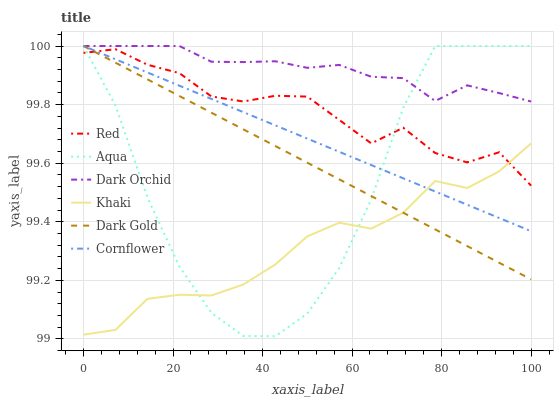Does Khaki have the minimum area under the curve?
Answer yes or no. Yes. Does Dark Orchid have the maximum area under the curve?
Answer yes or no. Yes. Does Dark Gold have the minimum area under the curve?
Answer yes or no. No. Does Dark Gold have the maximum area under the curve?
Answer yes or no. No. Is Cornflower the smoothest?
Answer yes or no. Yes. Is Aqua the roughest?
Answer yes or no. Yes. Is Khaki the smoothest?
Answer yes or no. No. Is Khaki the roughest?
Answer yes or no. No. Does Khaki have the lowest value?
Answer yes or no. No. Does Dark Orchid have the highest value?
Answer yes or no. Yes. Does Khaki have the highest value?
Answer yes or no. No. Is Khaki less than Dark Orchid?
Answer yes or no. Yes. Is Dark Orchid greater than Khaki?
Answer yes or no. Yes. Does Dark Gold intersect Khaki?
Answer yes or no. Yes. Is Dark Gold less than Khaki?
Answer yes or no. No. Is Dark Gold greater than Khaki?
Answer yes or no. No. Does Khaki intersect Dark Orchid?
Answer yes or no. No. 